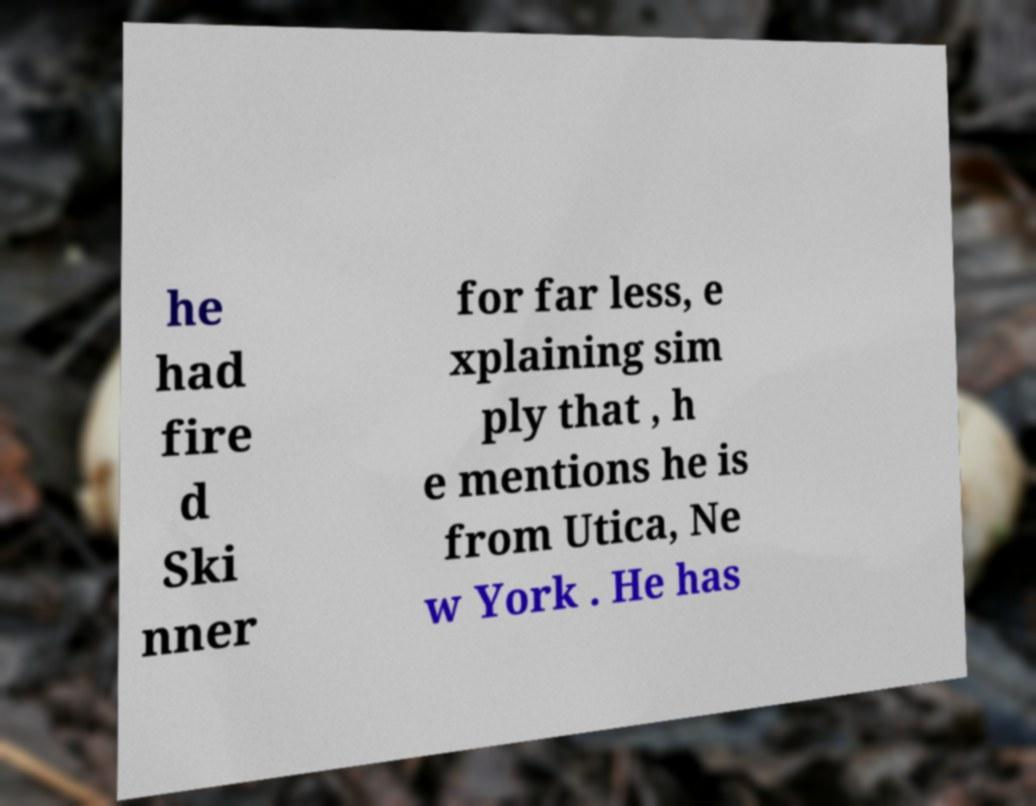Please read and relay the text visible in this image. What does it say? he had fire d Ski nner for far less, e xplaining sim ply that , h e mentions he is from Utica, Ne w York . He has 